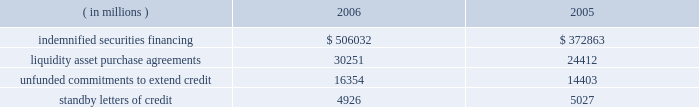State street bank issuances : state street bank currently has authority to issue up to an aggregate of $ 1 billion of subordinated fixed-rate , floating-rate or zero-coupon bank notes with a maturity of five to fifteen years .
With respect to the 5.25% ( 5.25 % ) subordinated bank notes due 2018 , state street bank is required to make semi-annual interest payments on the outstanding principal balance of the notes on april 15 and october 15 of each year , and the notes qualify as tier 2 capital under regulatory capital guidelines .
With respect to the 5.30% ( 5.30 % ) subordinated notes due 2016 and the floating-rate subordinated notes due 2015 , state street bank is required to make semi-annual interest payments on the outstanding principal balance of the 5.30% ( 5.30 % ) notes on january 15 and july 15 of each year beginning in july 2006 , and quarterly interest payments on the outstanding principal balance of the floating-rate notes on march 8 , june 8 , september 8 and december 8 of each year beginning in march 2006 .
The notes qualify as tier 2 capital under regulatory capital guidelines .
Note 10 .
Commitments and contingencies off-balance sheet commitments and contingencies : credit-related financial instruments include indemnified securities financing , unfunded commitments to extend credit or purchase assets and standby letters of credit .
The total potential loss on unfunded commitments , standby and commercial letters of credit and securities finance indemnifications is equal to the total contractual amount , which does not consider the value of any collateral .
The following is a summary of the contractual amount of credit-related , off-balance sheet financial instruments at december 31 .
Amounts reported do not reflect participations to unrelated third parties. .
On behalf of our customers , we lend their securities to creditworthy brokers and other institutions .
In certain circumstances , we may indemnify our customers for the fair market value of those securities against a failure of the borrower to return such securities .
Collateral funds received in connection with our securities finance services are held by us as agent and are not recorded in our consolidated statement of condition .
We require the borrowers to provide collateral in an amount equal to or in excess of 100% ( 100 % ) of the fair market value of the securities borrowed .
The borrowed securities are revalued daily to determine if additional collateral is necessary .
We held , as agent , cash and u.s .
Government securities totaling $ 527.37 billion and $ 387.22 billion as collateral for indemnified securities on loan at december 31 , 2006 and 2005 , respectively .
Approximately 81% ( 81 % ) of the unfunded commitments to extend credit and liquidity asset purchase agreements expire within one year from the date of issue .
Since many of the commitments are expected to expire or renew without being drawn upon , the total commitment amounts do not necessarily represent future cash requirements .
In the normal course of business , we provide liquidity and credit enhancements to asset-backed commercial paper programs , or 201cconduits . 201d these conduits are more fully described in note 11 .
The commercial paper issuances and commitments of the conduits to provide funding are supported by liquidity asset purchase agreements and backup liquidity lines of credit , the majority of which are provided by us .
In addition , we provide direct credit support to the conduits in the form of standby letters of credit .
Our commitments under liquidity asset purchase agreements and backup lines of credit totaled $ 23.99 billion at december 31 , 2006 , and are included in the preceding table .
Our commitments under seq 83 copyarea : 38 .
X 54 .
Trimsize : 8.25 x 10.75 typeset state street corporation serverprocess c:\\fc\\delivery_1024177\\2771-1-dm_p.pdf chksum : 0 cycle 1merrill corporation 07-2771-1 thu mar 01 17:10:46 2007 ( v 2.247w--stp1pae18 ) .
What percent did indemnified securities financing increase between 2005 and 2006? 
Computations: (372863 / 506032)
Answer: 0.73684. State street bank issuances : state street bank currently has authority to issue up to an aggregate of $ 1 billion of subordinated fixed-rate , floating-rate or zero-coupon bank notes with a maturity of five to fifteen years .
With respect to the 5.25% ( 5.25 % ) subordinated bank notes due 2018 , state street bank is required to make semi-annual interest payments on the outstanding principal balance of the notes on april 15 and october 15 of each year , and the notes qualify as tier 2 capital under regulatory capital guidelines .
With respect to the 5.30% ( 5.30 % ) subordinated notes due 2016 and the floating-rate subordinated notes due 2015 , state street bank is required to make semi-annual interest payments on the outstanding principal balance of the 5.30% ( 5.30 % ) notes on january 15 and july 15 of each year beginning in july 2006 , and quarterly interest payments on the outstanding principal balance of the floating-rate notes on march 8 , june 8 , september 8 and december 8 of each year beginning in march 2006 .
The notes qualify as tier 2 capital under regulatory capital guidelines .
Note 10 .
Commitments and contingencies off-balance sheet commitments and contingencies : credit-related financial instruments include indemnified securities financing , unfunded commitments to extend credit or purchase assets and standby letters of credit .
The total potential loss on unfunded commitments , standby and commercial letters of credit and securities finance indemnifications is equal to the total contractual amount , which does not consider the value of any collateral .
The following is a summary of the contractual amount of credit-related , off-balance sheet financial instruments at december 31 .
Amounts reported do not reflect participations to unrelated third parties. .
On behalf of our customers , we lend their securities to creditworthy brokers and other institutions .
In certain circumstances , we may indemnify our customers for the fair market value of those securities against a failure of the borrower to return such securities .
Collateral funds received in connection with our securities finance services are held by us as agent and are not recorded in our consolidated statement of condition .
We require the borrowers to provide collateral in an amount equal to or in excess of 100% ( 100 % ) of the fair market value of the securities borrowed .
The borrowed securities are revalued daily to determine if additional collateral is necessary .
We held , as agent , cash and u.s .
Government securities totaling $ 527.37 billion and $ 387.22 billion as collateral for indemnified securities on loan at december 31 , 2006 and 2005 , respectively .
Approximately 81% ( 81 % ) of the unfunded commitments to extend credit and liquidity asset purchase agreements expire within one year from the date of issue .
Since many of the commitments are expected to expire or renew without being drawn upon , the total commitment amounts do not necessarily represent future cash requirements .
In the normal course of business , we provide liquidity and credit enhancements to asset-backed commercial paper programs , or 201cconduits . 201d these conduits are more fully described in note 11 .
The commercial paper issuances and commitments of the conduits to provide funding are supported by liquidity asset purchase agreements and backup liquidity lines of credit , the majority of which are provided by us .
In addition , we provide direct credit support to the conduits in the form of standby letters of credit .
Our commitments under liquidity asset purchase agreements and backup lines of credit totaled $ 23.99 billion at december 31 , 2006 , and are included in the preceding table .
Our commitments under seq 83 copyarea : 38 .
X 54 .
Trimsize : 8.25 x 10.75 typeset state street corporation serverprocess c:\\fc\\delivery_1024177\\2771-1-dm_p.pdf chksum : 0 cycle 1merrill corporation 07-2771-1 thu mar 01 17:10:46 2007 ( v 2.247w--stp1pae18 ) .
What is the percentage change in the balance of indemnified securities financing from 2005 to 2006? 
Computations: ((506032 - 372863) / 372863)
Answer: 0.35715. State street bank issuances : state street bank currently has authority to issue up to an aggregate of $ 1 billion of subordinated fixed-rate , floating-rate or zero-coupon bank notes with a maturity of five to fifteen years .
With respect to the 5.25% ( 5.25 % ) subordinated bank notes due 2018 , state street bank is required to make semi-annual interest payments on the outstanding principal balance of the notes on april 15 and october 15 of each year , and the notes qualify as tier 2 capital under regulatory capital guidelines .
With respect to the 5.30% ( 5.30 % ) subordinated notes due 2016 and the floating-rate subordinated notes due 2015 , state street bank is required to make semi-annual interest payments on the outstanding principal balance of the 5.30% ( 5.30 % ) notes on january 15 and july 15 of each year beginning in july 2006 , and quarterly interest payments on the outstanding principal balance of the floating-rate notes on march 8 , june 8 , september 8 and december 8 of each year beginning in march 2006 .
The notes qualify as tier 2 capital under regulatory capital guidelines .
Note 10 .
Commitments and contingencies off-balance sheet commitments and contingencies : credit-related financial instruments include indemnified securities financing , unfunded commitments to extend credit or purchase assets and standby letters of credit .
The total potential loss on unfunded commitments , standby and commercial letters of credit and securities finance indemnifications is equal to the total contractual amount , which does not consider the value of any collateral .
The following is a summary of the contractual amount of credit-related , off-balance sheet financial instruments at december 31 .
Amounts reported do not reflect participations to unrelated third parties. .
On behalf of our customers , we lend their securities to creditworthy brokers and other institutions .
In certain circumstances , we may indemnify our customers for the fair market value of those securities against a failure of the borrower to return such securities .
Collateral funds received in connection with our securities finance services are held by us as agent and are not recorded in our consolidated statement of condition .
We require the borrowers to provide collateral in an amount equal to or in excess of 100% ( 100 % ) of the fair market value of the securities borrowed .
The borrowed securities are revalued daily to determine if additional collateral is necessary .
We held , as agent , cash and u.s .
Government securities totaling $ 527.37 billion and $ 387.22 billion as collateral for indemnified securities on loan at december 31 , 2006 and 2005 , respectively .
Approximately 81% ( 81 % ) of the unfunded commitments to extend credit and liquidity asset purchase agreements expire within one year from the date of issue .
Since many of the commitments are expected to expire or renew without being drawn upon , the total commitment amounts do not necessarily represent future cash requirements .
In the normal course of business , we provide liquidity and credit enhancements to asset-backed commercial paper programs , or 201cconduits . 201d these conduits are more fully described in note 11 .
The commercial paper issuances and commitments of the conduits to provide funding are supported by liquidity asset purchase agreements and backup liquidity lines of credit , the majority of which are provided by us .
In addition , we provide direct credit support to the conduits in the form of standby letters of credit .
Our commitments under liquidity asset purchase agreements and backup lines of credit totaled $ 23.99 billion at december 31 , 2006 , and are included in the preceding table .
Our commitments under seq 83 copyarea : 38 .
X 54 .
Trimsize : 8.25 x 10.75 typeset state street corporation serverprocess c:\\fc\\delivery_1024177\\2771-1-dm_p.pdf chksum : 0 cycle 1merrill corporation 07-2771-1 thu mar 01 17:10:46 2007 ( v 2.247w--stp1pae18 ) .
What is the net change in the balance of cash and u.s . government securities held as collateral for indemnified securities on loans in 2006? 
Computations: (527.37 - 387.22)
Answer: 140.15. 